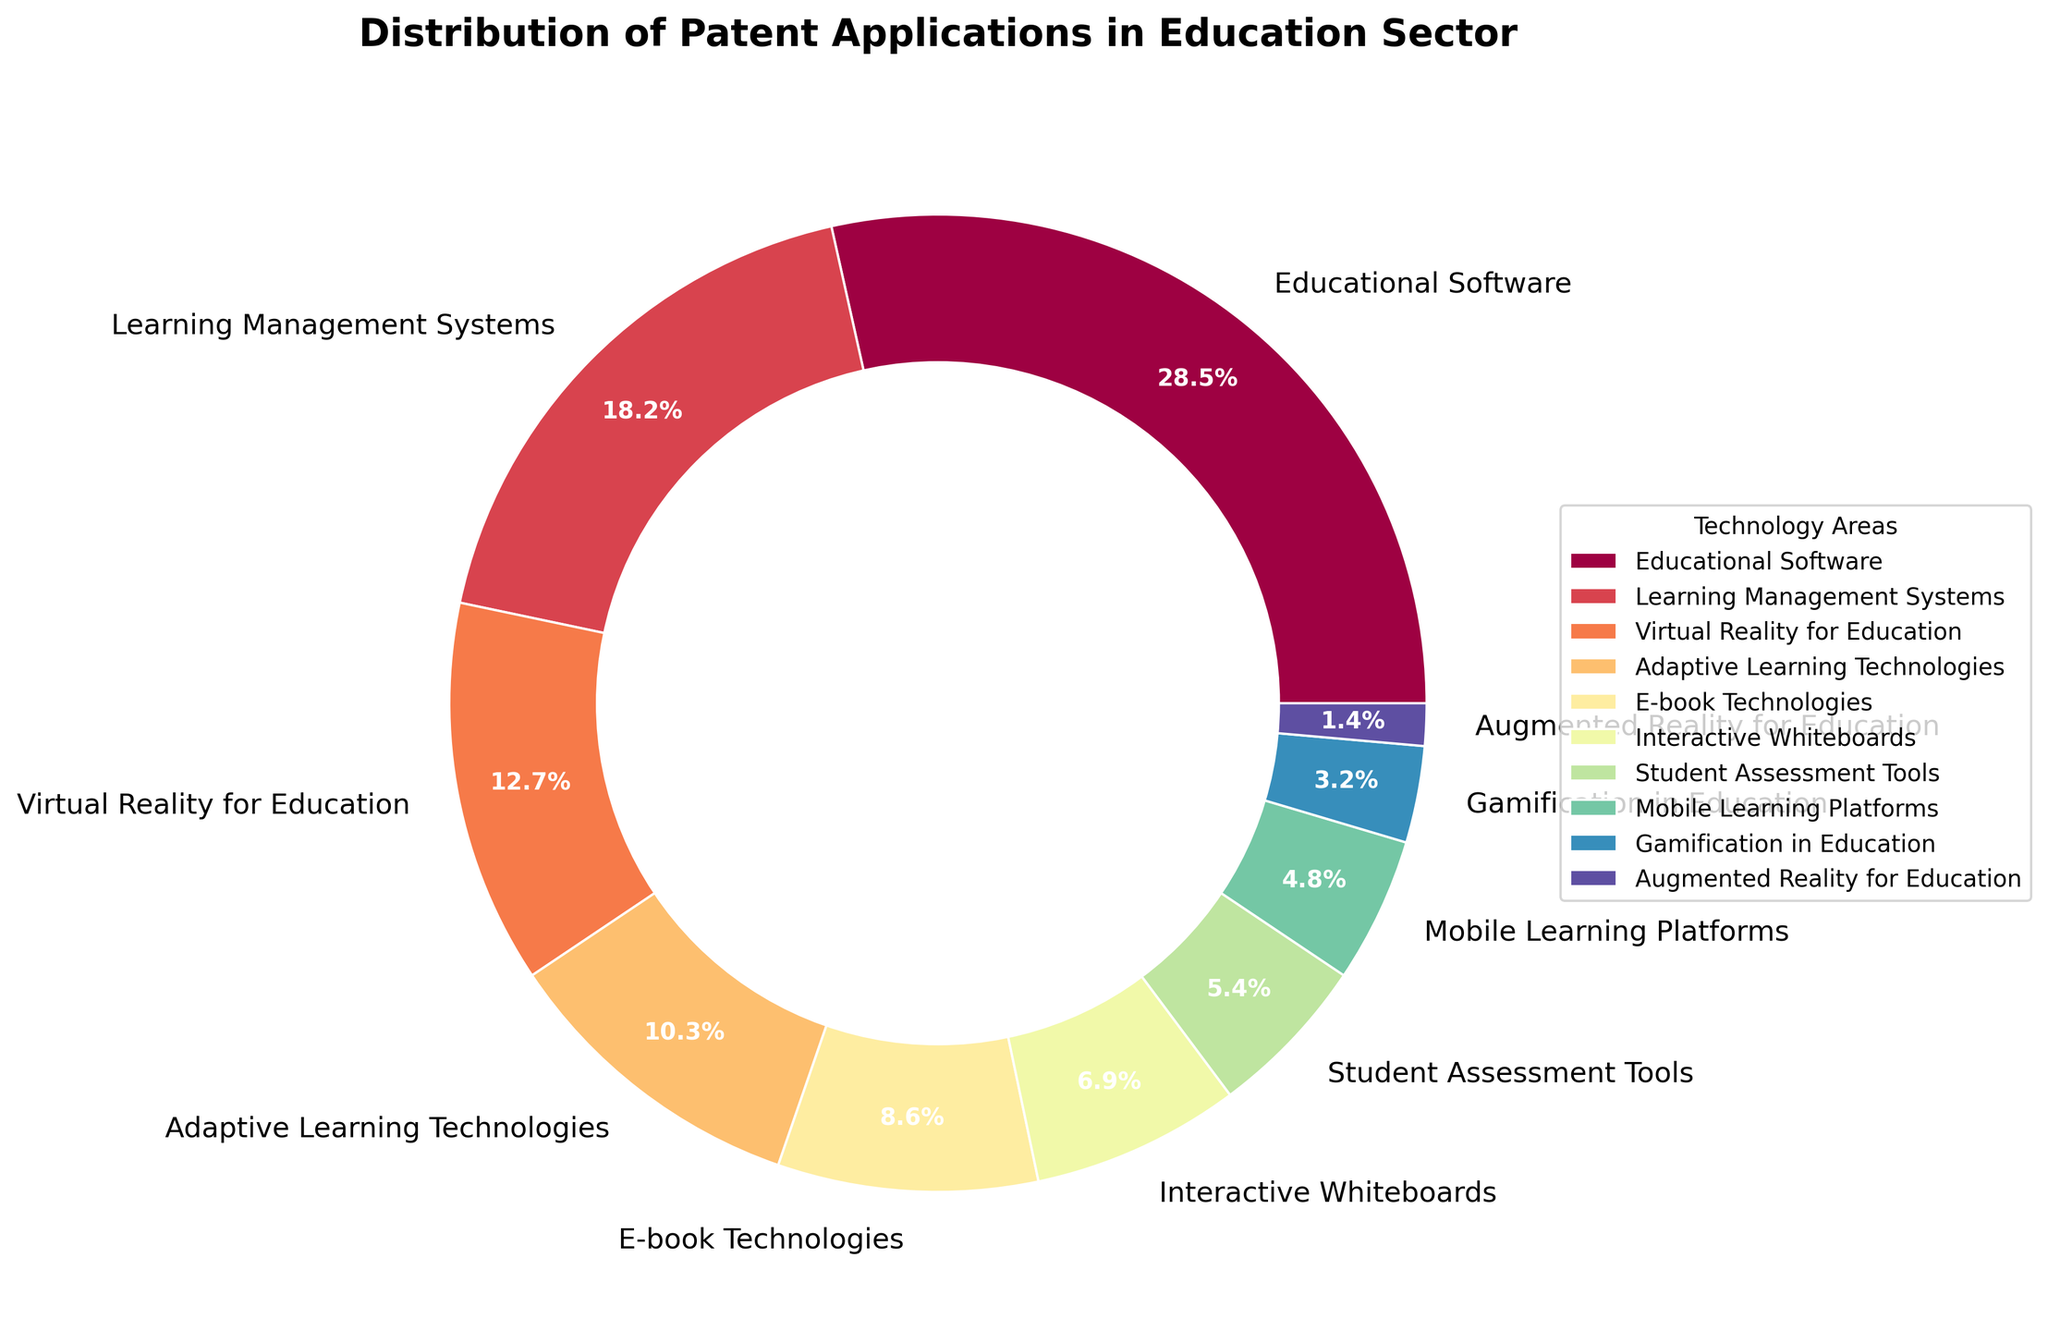Which technology area has the highest percentage of patent applications? The pie chart shows various technology areas in education with their respective percentages. The largest section corresponds to Educational Software with 28.5%.
Answer: Educational Software Which two technology areas have the smallest percentages of patent applications and what are they? The smallest slices on the pie chart are Augmented Reality for Education at 1.4% and Gamification in Education at 3.2%.
Answer: Augmented Reality for Education and Gamification in Education How much more is the percentage of patent applications in Learning Management Systems compared to Mobile Learning Platforms? From the pie chart, Learning Management Systems have 18.2% and Mobile Learning Platforms have 4.8%. The difference is calculated as 18.2% - 4.8% = 13.4%.
Answer: 13.4% What is the combined percentage of patent applications in Adaptive Learning Technologies and Student Assessment Tools? Adaptive Learning Technologies have 10.3% and Student Assessment Tools have 5.4%. Combining these, we get 10.3% + 5.4% = 15.7%.
Answer: 15.7% If you sum the percentages of the three largest technology areas, what do you get? The three largest technology areas are Educational Software (28.5%), Learning Management Systems (18.2%), and Virtual Reality for Education (12.7%). The sum is 28.5% + 18.2% + 12.7% = 59.4%.
Answer: 59.4% Is the percentage of patent applications in Interactive Whiteboards greater than that in E-book Technologies? Comparing the percentages from the pie chart, E-book Technologies have 8.6%, while Interactive Whiteboards have 6.9%. Since 8.6% is greater than 6.9%, the answer is no.
Answer: No How does the percentage of patent applications in Educational Software compare to the sum of Gamification in Education and Augmented Reality for Education? The percentage for Educational Software is 28.5%. Gamification in Education is 3.2% and Augmented Reality for Education is 1.4%. The sum of the latter two is 3.2% + 1.4% = 4.6%, which is less than 28.5%.
Answer: Educational Software is greater What is the average percentage of patent applications for Virtual Reality for Education, Adaptive Learning Technologies, and Mobile Learning Platforms? Finding the average involves summing the percentages and dividing by the number of categories: (12.7% + 10.3% + 4.8%) / 3 = 27.8% / 3 ≈ 9.27%.
Answer: 9.27% 